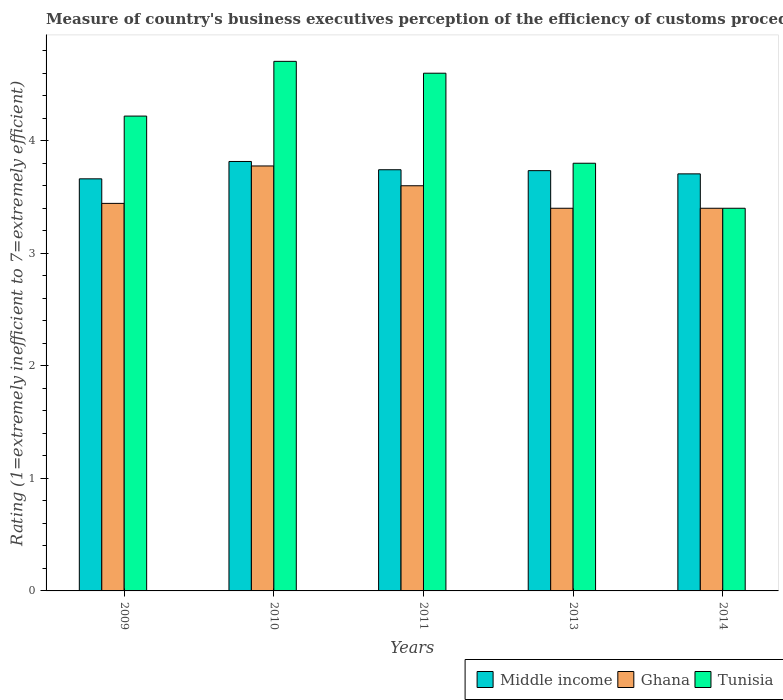How many different coloured bars are there?
Your answer should be compact. 3. Are the number of bars per tick equal to the number of legend labels?
Your answer should be compact. Yes. How many bars are there on the 2nd tick from the left?
Your answer should be very brief. 3. How many bars are there on the 5th tick from the right?
Provide a short and direct response. 3. What is the rating of the efficiency of customs procedure in Ghana in 2009?
Give a very brief answer. 3.44. Across all years, what is the maximum rating of the efficiency of customs procedure in Ghana?
Offer a very short reply. 3.78. Across all years, what is the minimum rating of the efficiency of customs procedure in Middle income?
Give a very brief answer. 3.66. In which year was the rating of the efficiency of customs procedure in Tunisia minimum?
Offer a very short reply. 2014. What is the total rating of the efficiency of customs procedure in Tunisia in the graph?
Ensure brevity in your answer.  20.72. What is the difference between the rating of the efficiency of customs procedure in Middle income in 2009 and that in 2014?
Provide a short and direct response. -0.04. What is the difference between the rating of the efficiency of customs procedure in Ghana in 2010 and the rating of the efficiency of customs procedure in Tunisia in 2013?
Ensure brevity in your answer.  -0.02. What is the average rating of the efficiency of customs procedure in Middle income per year?
Make the answer very short. 3.73. In the year 2014, what is the difference between the rating of the efficiency of customs procedure in Middle income and rating of the efficiency of customs procedure in Tunisia?
Ensure brevity in your answer.  0.31. What is the ratio of the rating of the efficiency of customs procedure in Middle income in 2010 to that in 2014?
Your answer should be compact. 1.03. Is the difference between the rating of the efficiency of customs procedure in Middle income in 2013 and 2014 greater than the difference between the rating of the efficiency of customs procedure in Tunisia in 2013 and 2014?
Your response must be concise. No. What is the difference between the highest and the second highest rating of the efficiency of customs procedure in Tunisia?
Your response must be concise. 0.11. What is the difference between the highest and the lowest rating of the efficiency of customs procedure in Tunisia?
Offer a terse response. 1.31. In how many years, is the rating of the efficiency of customs procedure in Ghana greater than the average rating of the efficiency of customs procedure in Ghana taken over all years?
Your response must be concise. 2. What does the 3rd bar from the left in 2010 represents?
Keep it short and to the point. Tunisia. What does the 1st bar from the right in 2013 represents?
Give a very brief answer. Tunisia. How many years are there in the graph?
Offer a terse response. 5. Are the values on the major ticks of Y-axis written in scientific E-notation?
Make the answer very short. No. Does the graph contain any zero values?
Ensure brevity in your answer.  No. Does the graph contain grids?
Give a very brief answer. No. Where does the legend appear in the graph?
Make the answer very short. Bottom right. How are the legend labels stacked?
Provide a succinct answer. Horizontal. What is the title of the graph?
Your answer should be very brief. Measure of country's business executives perception of the efficiency of customs procedures. Does "Angola" appear as one of the legend labels in the graph?
Your answer should be compact. No. What is the label or title of the Y-axis?
Your response must be concise. Rating (1=extremely inefficient to 7=extremely efficient). What is the Rating (1=extremely inefficient to 7=extremely efficient) of Middle income in 2009?
Provide a succinct answer. 3.66. What is the Rating (1=extremely inefficient to 7=extremely efficient) of Ghana in 2009?
Offer a very short reply. 3.44. What is the Rating (1=extremely inefficient to 7=extremely efficient) in Tunisia in 2009?
Offer a terse response. 4.22. What is the Rating (1=extremely inefficient to 7=extremely efficient) in Middle income in 2010?
Your answer should be compact. 3.82. What is the Rating (1=extremely inefficient to 7=extremely efficient) of Ghana in 2010?
Offer a terse response. 3.78. What is the Rating (1=extremely inefficient to 7=extremely efficient) of Tunisia in 2010?
Give a very brief answer. 4.71. What is the Rating (1=extremely inefficient to 7=extremely efficient) of Middle income in 2011?
Your answer should be very brief. 3.74. What is the Rating (1=extremely inefficient to 7=extremely efficient) in Ghana in 2011?
Offer a terse response. 3.6. What is the Rating (1=extremely inefficient to 7=extremely efficient) in Tunisia in 2011?
Provide a short and direct response. 4.6. What is the Rating (1=extremely inefficient to 7=extremely efficient) of Middle income in 2013?
Give a very brief answer. 3.73. What is the Rating (1=extremely inefficient to 7=extremely efficient) of Middle income in 2014?
Provide a short and direct response. 3.71. What is the Rating (1=extremely inefficient to 7=extremely efficient) of Ghana in 2014?
Keep it short and to the point. 3.4. What is the Rating (1=extremely inefficient to 7=extremely efficient) in Tunisia in 2014?
Offer a very short reply. 3.4. Across all years, what is the maximum Rating (1=extremely inefficient to 7=extremely efficient) of Middle income?
Ensure brevity in your answer.  3.82. Across all years, what is the maximum Rating (1=extremely inefficient to 7=extremely efficient) of Ghana?
Your response must be concise. 3.78. Across all years, what is the maximum Rating (1=extremely inefficient to 7=extremely efficient) of Tunisia?
Make the answer very short. 4.71. Across all years, what is the minimum Rating (1=extremely inefficient to 7=extremely efficient) in Middle income?
Keep it short and to the point. 3.66. What is the total Rating (1=extremely inefficient to 7=extremely efficient) in Middle income in the graph?
Ensure brevity in your answer.  18.66. What is the total Rating (1=extremely inefficient to 7=extremely efficient) in Ghana in the graph?
Your answer should be compact. 17.62. What is the total Rating (1=extremely inefficient to 7=extremely efficient) in Tunisia in the graph?
Provide a succinct answer. 20.72. What is the difference between the Rating (1=extremely inefficient to 7=extremely efficient) in Middle income in 2009 and that in 2010?
Provide a succinct answer. -0.15. What is the difference between the Rating (1=extremely inefficient to 7=extremely efficient) of Ghana in 2009 and that in 2010?
Make the answer very short. -0.33. What is the difference between the Rating (1=extremely inefficient to 7=extremely efficient) of Tunisia in 2009 and that in 2010?
Make the answer very short. -0.49. What is the difference between the Rating (1=extremely inefficient to 7=extremely efficient) in Middle income in 2009 and that in 2011?
Offer a terse response. -0.08. What is the difference between the Rating (1=extremely inefficient to 7=extremely efficient) of Ghana in 2009 and that in 2011?
Keep it short and to the point. -0.16. What is the difference between the Rating (1=extremely inefficient to 7=extremely efficient) in Tunisia in 2009 and that in 2011?
Your answer should be very brief. -0.38. What is the difference between the Rating (1=extremely inefficient to 7=extremely efficient) in Middle income in 2009 and that in 2013?
Offer a very short reply. -0.07. What is the difference between the Rating (1=extremely inefficient to 7=extremely efficient) of Ghana in 2009 and that in 2013?
Ensure brevity in your answer.  0.04. What is the difference between the Rating (1=extremely inefficient to 7=extremely efficient) in Tunisia in 2009 and that in 2013?
Your answer should be compact. 0.42. What is the difference between the Rating (1=extremely inefficient to 7=extremely efficient) of Middle income in 2009 and that in 2014?
Your answer should be very brief. -0.04. What is the difference between the Rating (1=extremely inefficient to 7=extremely efficient) in Ghana in 2009 and that in 2014?
Offer a very short reply. 0.04. What is the difference between the Rating (1=extremely inefficient to 7=extremely efficient) in Tunisia in 2009 and that in 2014?
Your answer should be very brief. 0.82. What is the difference between the Rating (1=extremely inefficient to 7=extremely efficient) in Middle income in 2010 and that in 2011?
Provide a succinct answer. 0.07. What is the difference between the Rating (1=extremely inefficient to 7=extremely efficient) in Ghana in 2010 and that in 2011?
Your answer should be very brief. 0.18. What is the difference between the Rating (1=extremely inefficient to 7=extremely efficient) of Tunisia in 2010 and that in 2011?
Make the answer very short. 0.11. What is the difference between the Rating (1=extremely inefficient to 7=extremely efficient) in Middle income in 2010 and that in 2013?
Your answer should be very brief. 0.08. What is the difference between the Rating (1=extremely inefficient to 7=extremely efficient) in Ghana in 2010 and that in 2013?
Provide a short and direct response. 0.38. What is the difference between the Rating (1=extremely inefficient to 7=extremely efficient) in Tunisia in 2010 and that in 2013?
Your answer should be very brief. 0.91. What is the difference between the Rating (1=extremely inefficient to 7=extremely efficient) in Middle income in 2010 and that in 2014?
Provide a succinct answer. 0.11. What is the difference between the Rating (1=extremely inefficient to 7=extremely efficient) of Ghana in 2010 and that in 2014?
Make the answer very short. 0.38. What is the difference between the Rating (1=extremely inefficient to 7=extremely efficient) in Tunisia in 2010 and that in 2014?
Make the answer very short. 1.31. What is the difference between the Rating (1=extremely inefficient to 7=extremely efficient) in Middle income in 2011 and that in 2013?
Keep it short and to the point. 0.01. What is the difference between the Rating (1=extremely inefficient to 7=extremely efficient) in Ghana in 2011 and that in 2013?
Offer a very short reply. 0.2. What is the difference between the Rating (1=extremely inefficient to 7=extremely efficient) of Middle income in 2011 and that in 2014?
Your response must be concise. 0.04. What is the difference between the Rating (1=extremely inefficient to 7=extremely efficient) in Middle income in 2013 and that in 2014?
Offer a terse response. 0.03. What is the difference between the Rating (1=extremely inefficient to 7=extremely efficient) in Middle income in 2009 and the Rating (1=extremely inefficient to 7=extremely efficient) in Ghana in 2010?
Your answer should be very brief. -0.11. What is the difference between the Rating (1=extremely inefficient to 7=extremely efficient) of Middle income in 2009 and the Rating (1=extremely inefficient to 7=extremely efficient) of Tunisia in 2010?
Provide a short and direct response. -1.04. What is the difference between the Rating (1=extremely inefficient to 7=extremely efficient) in Ghana in 2009 and the Rating (1=extremely inefficient to 7=extremely efficient) in Tunisia in 2010?
Provide a short and direct response. -1.26. What is the difference between the Rating (1=extremely inefficient to 7=extremely efficient) of Middle income in 2009 and the Rating (1=extremely inefficient to 7=extremely efficient) of Ghana in 2011?
Make the answer very short. 0.06. What is the difference between the Rating (1=extremely inefficient to 7=extremely efficient) in Middle income in 2009 and the Rating (1=extremely inefficient to 7=extremely efficient) in Tunisia in 2011?
Keep it short and to the point. -0.94. What is the difference between the Rating (1=extremely inefficient to 7=extremely efficient) in Ghana in 2009 and the Rating (1=extremely inefficient to 7=extremely efficient) in Tunisia in 2011?
Keep it short and to the point. -1.16. What is the difference between the Rating (1=extremely inefficient to 7=extremely efficient) of Middle income in 2009 and the Rating (1=extremely inefficient to 7=extremely efficient) of Ghana in 2013?
Offer a very short reply. 0.26. What is the difference between the Rating (1=extremely inefficient to 7=extremely efficient) of Middle income in 2009 and the Rating (1=extremely inefficient to 7=extremely efficient) of Tunisia in 2013?
Offer a very short reply. -0.14. What is the difference between the Rating (1=extremely inefficient to 7=extremely efficient) of Ghana in 2009 and the Rating (1=extremely inefficient to 7=extremely efficient) of Tunisia in 2013?
Provide a succinct answer. -0.36. What is the difference between the Rating (1=extremely inefficient to 7=extremely efficient) of Middle income in 2009 and the Rating (1=extremely inefficient to 7=extremely efficient) of Ghana in 2014?
Your answer should be compact. 0.26. What is the difference between the Rating (1=extremely inefficient to 7=extremely efficient) in Middle income in 2009 and the Rating (1=extremely inefficient to 7=extremely efficient) in Tunisia in 2014?
Ensure brevity in your answer.  0.26. What is the difference between the Rating (1=extremely inefficient to 7=extremely efficient) in Ghana in 2009 and the Rating (1=extremely inefficient to 7=extremely efficient) in Tunisia in 2014?
Make the answer very short. 0.04. What is the difference between the Rating (1=extremely inefficient to 7=extremely efficient) in Middle income in 2010 and the Rating (1=extremely inefficient to 7=extremely efficient) in Ghana in 2011?
Your answer should be compact. 0.22. What is the difference between the Rating (1=extremely inefficient to 7=extremely efficient) in Middle income in 2010 and the Rating (1=extremely inefficient to 7=extremely efficient) in Tunisia in 2011?
Provide a short and direct response. -0.78. What is the difference between the Rating (1=extremely inefficient to 7=extremely efficient) in Ghana in 2010 and the Rating (1=extremely inefficient to 7=extremely efficient) in Tunisia in 2011?
Offer a very short reply. -0.82. What is the difference between the Rating (1=extremely inefficient to 7=extremely efficient) in Middle income in 2010 and the Rating (1=extremely inefficient to 7=extremely efficient) in Ghana in 2013?
Provide a succinct answer. 0.42. What is the difference between the Rating (1=extremely inefficient to 7=extremely efficient) in Middle income in 2010 and the Rating (1=extremely inefficient to 7=extremely efficient) in Tunisia in 2013?
Ensure brevity in your answer.  0.02. What is the difference between the Rating (1=extremely inefficient to 7=extremely efficient) of Ghana in 2010 and the Rating (1=extremely inefficient to 7=extremely efficient) of Tunisia in 2013?
Your answer should be compact. -0.02. What is the difference between the Rating (1=extremely inefficient to 7=extremely efficient) of Middle income in 2010 and the Rating (1=extremely inefficient to 7=extremely efficient) of Ghana in 2014?
Make the answer very short. 0.42. What is the difference between the Rating (1=extremely inefficient to 7=extremely efficient) of Middle income in 2010 and the Rating (1=extremely inefficient to 7=extremely efficient) of Tunisia in 2014?
Provide a succinct answer. 0.42. What is the difference between the Rating (1=extremely inefficient to 7=extremely efficient) in Ghana in 2010 and the Rating (1=extremely inefficient to 7=extremely efficient) in Tunisia in 2014?
Ensure brevity in your answer.  0.38. What is the difference between the Rating (1=extremely inefficient to 7=extremely efficient) in Middle income in 2011 and the Rating (1=extremely inefficient to 7=extremely efficient) in Ghana in 2013?
Keep it short and to the point. 0.34. What is the difference between the Rating (1=extremely inefficient to 7=extremely efficient) in Middle income in 2011 and the Rating (1=extremely inefficient to 7=extremely efficient) in Tunisia in 2013?
Offer a terse response. -0.06. What is the difference between the Rating (1=extremely inefficient to 7=extremely efficient) in Ghana in 2011 and the Rating (1=extremely inefficient to 7=extremely efficient) in Tunisia in 2013?
Your answer should be compact. -0.2. What is the difference between the Rating (1=extremely inefficient to 7=extremely efficient) of Middle income in 2011 and the Rating (1=extremely inefficient to 7=extremely efficient) of Ghana in 2014?
Your answer should be very brief. 0.34. What is the difference between the Rating (1=extremely inefficient to 7=extremely efficient) of Middle income in 2011 and the Rating (1=extremely inefficient to 7=extremely efficient) of Tunisia in 2014?
Provide a succinct answer. 0.34. What is the difference between the Rating (1=extremely inefficient to 7=extremely efficient) of Middle income in 2013 and the Rating (1=extremely inefficient to 7=extremely efficient) of Ghana in 2014?
Give a very brief answer. 0.33. What is the difference between the Rating (1=extremely inefficient to 7=extremely efficient) in Middle income in 2013 and the Rating (1=extremely inefficient to 7=extremely efficient) in Tunisia in 2014?
Give a very brief answer. 0.33. What is the average Rating (1=extremely inefficient to 7=extremely efficient) in Middle income per year?
Offer a terse response. 3.73. What is the average Rating (1=extremely inefficient to 7=extremely efficient) in Ghana per year?
Give a very brief answer. 3.52. What is the average Rating (1=extremely inefficient to 7=extremely efficient) in Tunisia per year?
Keep it short and to the point. 4.14. In the year 2009, what is the difference between the Rating (1=extremely inefficient to 7=extremely efficient) of Middle income and Rating (1=extremely inefficient to 7=extremely efficient) of Ghana?
Your answer should be compact. 0.22. In the year 2009, what is the difference between the Rating (1=extremely inefficient to 7=extremely efficient) of Middle income and Rating (1=extremely inefficient to 7=extremely efficient) of Tunisia?
Offer a very short reply. -0.56. In the year 2009, what is the difference between the Rating (1=extremely inefficient to 7=extremely efficient) in Ghana and Rating (1=extremely inefficient to 7=extremely efficient) in Tunisia?
Your response must be concise. -0.78. In the year 2010, what is the difference between the Rating (1=extremely inefficient to 7=extremely efficient) of Middle income and Rating (1=extremely inefficient to 7=extremely efficient) of Ghana?
Your response must be concise. 0.04. In the year 2010, what is the difference between the Rating (1=extremely inefficient to 7=extremely efficient) of Middle income and Rating (1=extremely inefficient to 7=extremely efficient) of Tunisia?
Ensure brevity in your answer.  -0.89. In the year 2010, what is the difference between the Rating (1=extremely inefficient to 7=extremely efficient) in Ghana and Rating (1=extremely inefficient to 7=extremely efficient) in Tunisia?
Your answer should be compact. -0.93. In the year 2011, what is the difference between the Rating (1=extremely inefficient to 7=extremely efficient) in Middle income and Rating (1=extremely inefficient to 7=extremely efficient) in Ghana?
Provide a short and direct response. 0.14. In the year 2011, what is the difference between the Rating (1=extremely inefficient to 7=extremely efficient) in Middle income and Rating (1=extremely inefficient to 7=extremely efficient) in Tunisia?
Offer a very short reply. -0.86. In the year 2013, what is the difference between the Rating (1=extremely inefficient to 7=extremely efficient) of Middle income and Rating (1=extremely inefficient to 7=extremely efficient) of Ghana?
Your response must be concise. 0.33. In the year 2013, what is the difference between the Rating (1=extremely inefficient to 7=extremely efficient) of Middle income and Rating (1=extremely inefficient to 7=extremely efficient) of Tunisia?
Your answer should be compact. -0.07. In the year 2013, what is the difference between the Rating (1=extremely inefficient to 7=extremely efficient) in Ghana and Rating (1=extremely inefficient to 7=extremely efficient) in Tunisia?
Offer a terse response. -0.4. In the year 2014, what is the difference between the Rating (1=extremely inefficient to 7=extremely efficient) of Middle income and Rating (1=extremely inefficient to 7=extremely efficient) of Ghana?
Your response must be concise. 0.31. In the year 2014, what is the difference between the Rating (1=extremely inefficient to 7=extremely efficient) of Middle income and Rating (1=extremely inefficient to 7=extremely efficient) of Tunisia?
Offer a very short reply. 0.31. What is the ratio of the Rating (1=extremely inefficient to 7=extremely efficient) in Middle income in 2009 to that in 2010?
Your answer should be compact. 0.96. What is the ratio of the Rating (1=extremely inefficient to 7=extremely efficient) in Ghana in 2009 to that in 2010?
Give a very brief answer. 0.91. What is the ratio of the Rating (1=extremely inefficient to 7=extremely efficient) of Tunisia in 2009 to that in 2010?
Ensure brevity in your answer.  0.9. What is the ratio of the Rating (1=extremely inefficient to 7=extremely efficient) of Middle income in 2009 to that in 2011?
Make the answer very short. 0.98. What is the ratio of the Rating (1=extremely inefficient to 7=extremely efficient) in Ghana in 2009 to that in 2011?
Provide a short and direct response. 0.96. What is the ratio of the Rating (1=extremely inefficient to 7=extremely efficient) in Tunisia in 2009 to that in 2011?
Provide a short and direct response. 0.92. What is the ratio of the Rating (1=extremely inefficient to 7=extremely efficient) of Middle income in 2009 to that in 2013?
Ensure brevity in your answer.  0.98. What is the ratio of the Rating (1=extremely inefficient to 7=extremely efficient) in Ghana in 2009 to that in 2013?
Ensure brevity in your answer.  1.01. What is the ratio of the Rating (1=extremely inefficient to 7=extremely efficient) of Tunisia in 2009 to that in 2013?
Keep it short and to the point. 1.11. What is the ratio of the Rating (1=extremely inefficient to 7=extremely efficient) of Ghana in 2009 to that in 2014?
Make the answer very short. 1.01. What is the ratio of the Rating (1=extremely inefficient to 7=extremely efficient) in Tunisia in 2009 to that in 2014?
Ensure brevity in your answer.  1.24. What is the ratio of the Rating (1=extremely inefficient to 7=extremely efficient) of Middle income in 2010 to that in 2011?
Your answer should be compact. 1.02. What is the ratio of the Rating (1=extremely inefficient to 7=extremely efficient) of Ghana in 2010 to that in 2011?
Provide a short and direct response. 1.05. What is the ratio of the Rating (1=extremely inefficient to 7=extremely efficient) in Tunisia in 2010 to that in 2011?
Make the answer very short. 1.02. What is the ratio of the Rating (1=extremely inefficient to 7=extremely efficient) in Middle income in 2010 to that in 2013?
Keep it short and to the point. 1.02. What is the ratio of the Rating (1=extremely inefficient to 7=extremely efficient) in Ghana in 2010 to that in 2013?
Offer a terse response. 1.11. What is the ratio of the Rating (1=extremely inefficient to 7=extremely efficient) of Tunisia in 2010 to that in 2013?
Provide a short and direct response. 1.24. What is the ratio of the Rating (1=extremely inefficient to 7=extremely efficient) in Middle income in 2010 to that in 2014?
Your answer should be compact. 1.03. What is the ratio of the Rating (1=extremely inefficient to 7=extremely efficient) in Ghana in 2010 to that in 2014?
Offer a terse response. 1.11. What is the ratio of the Rating (1=extremely inefficient to 7=extremely efficient) in Tunisia in 2010 to that in 2014?
Offer a terse response. 1.38. What is the ratio of the Rating (1=extremely inefficient to 7=extremely efficient) in Ghana in 2011 to that in 2013?
Ensure brevity in your answer.  1.06. What is the ratio of the Rating (1=extremely inefficient to 7=extremely efficient) in Tunisia in 2011 to that in 2013?
Make the answer very short. 1.21. What is the ratio of the Rating (1=extremely inefficient to 7=extremely efficient) in Middle income in 2011 to that in 2014?
Your response must be concise. 1.01. What is the ratio of the Rating (1=extremely inefficient to 7=extremely efficient) of Ghana in 2011 to that in 2014?
Your response must be concise. 1.06. What is the ratio of the Rating (1=extremely inefficient to 7=extremely efficient) in Tunisia in 2011 to that in 2014?
Your response must be concise. 1.35. What is the ratio of the Rating (1=extremely inefficient to 7=extremely efficient) in Middle income in 2013 to that in 2014?
Offer a terse response. 1.01. What is the ratio of the Rating (1=extremely inefficient to 7=extremely efficient) of Tunisia in 2013 to that in 2014?
Keep it short and to the point. 1.12. What is the difference between the highest and the second highest Rating (1=extremely inefficient to 7=extremely efficient) in Middle income?
Your answer should be compact. 0.07. What is the difference between the highest and the second highest Rating (1=extremely inefficient to 7=extremely efficient) of Ghana?
Make the answer very short. 0.18. What is the difference between the highest and the second highest Rating (1=extremely inefficient to 7=extremely efficient) in Tunisia?
Provide a short and direct response. 0.11. What is the difference between the highest and the lowest Rating (1=extremely inefficient to 7=extremely efficient) of Middle income?
Provide a short and direct response. 0.15. What is the difference between the highest and the lowest Rating (1=extremely inefficient to 7=extremely efficient) of Ghana?
Your answer should be compact. 0.38. What is the difference between the highest and the lowest Rating (1=extremely inefficient to 7=extremely efficient) of Tunisia?
Offer a very short reply. 1.31. 